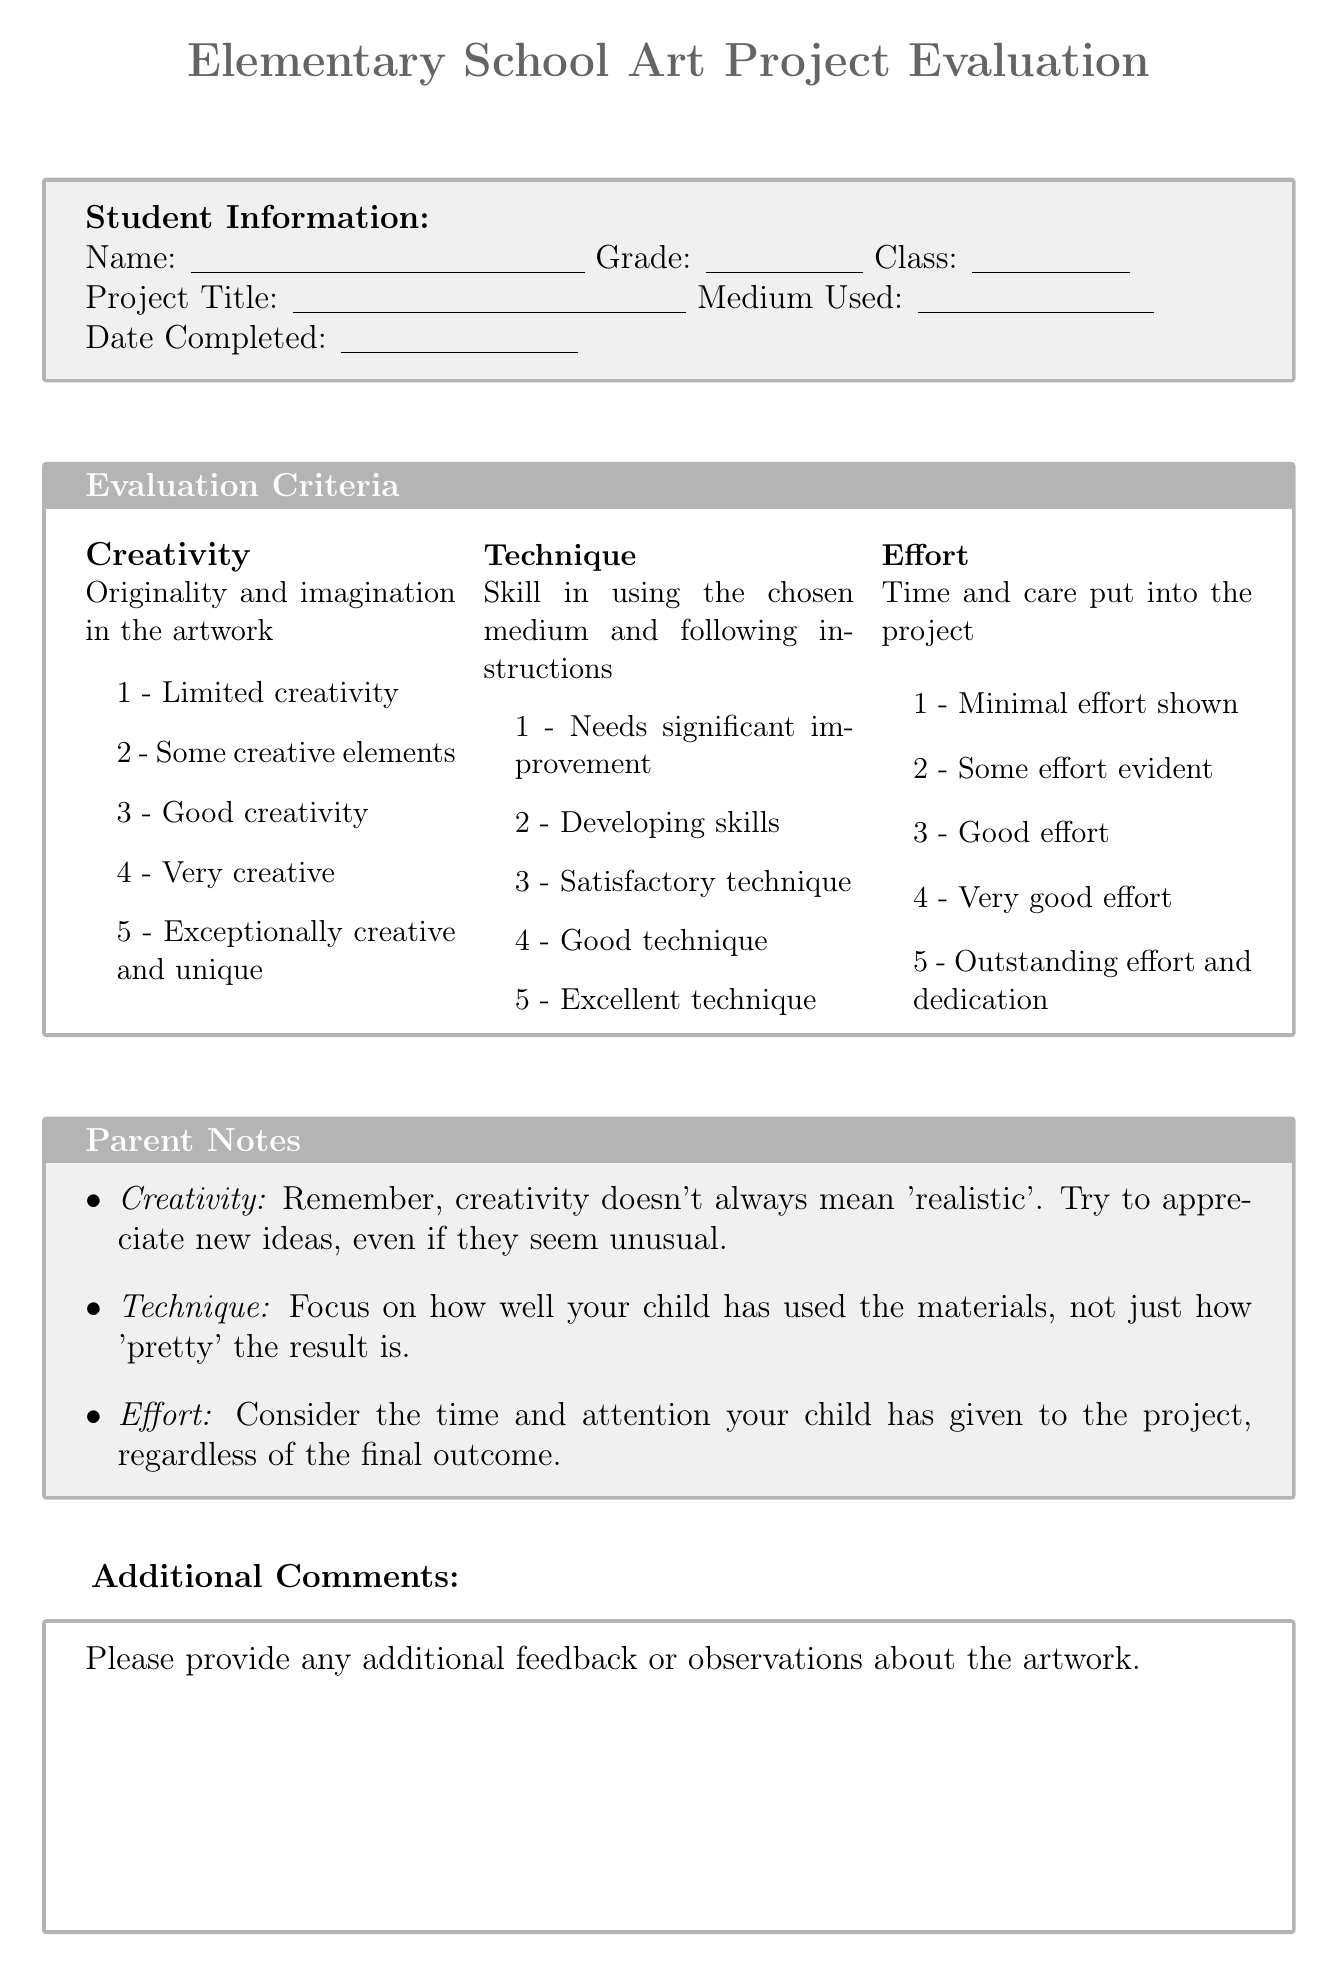What is the title of the evaluation form? The title of the evaluation form is found at the top of the document.
Answer: Elementary School Art Project Evaluation What is the name of the art teacher? The name of the art teacher is mentioned in the document.
Answer: Ms. Sarah Johnson What date is the annual student art exhibition scheduled for? The date of the annual student art exhibition is listed in the document.
Answer: May 15-20, 2023 Which medium is used by the student? The medium used by the student is requested in the project details section of the document.
Answer: Medium Used On what criteria is creativity evaluated? The criteria for evaluating creativity is described within the evaluation section.
Answer: Originality and imagination in the artwork What is the highest rating for effort? The rating scale for effort allows for various evaluations which include a maximum score.
Answer: 5 What type of comments does the evaluation form ask for? The form includes a section dedicated to feedback related to the artwork.
Answer: Additional Comments What should parents remember about creativity? A note is provided for parents to consider when evaluating creativity.
Answer: Creativity doesn't always mean 'realistic' How long should parents take to return the form? A reminder in the document specifies the timeframe for returning the form.
Answer: One week What is expected in the "Technique" evaluation? The "Technique" section contains a description regarding the evaluation focus.
Answer: Skill in using the chosen medium and following instructions 